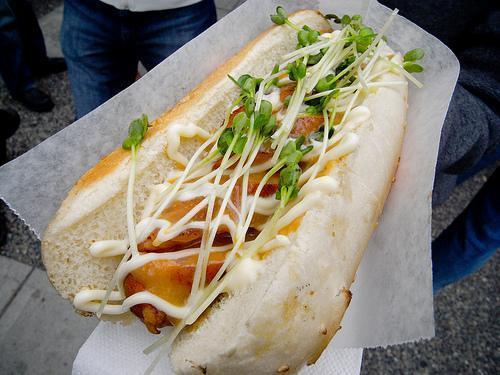How many airplanes are pictured?
Give a very brief answer. 0. 